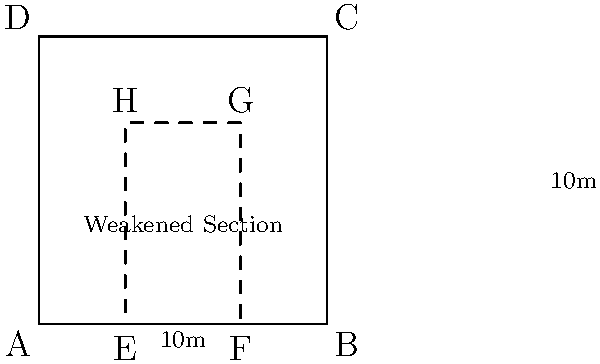In an abandoned building, you notice a weakened section in the wall as shown in the cross-section diagram. If the building is 10m x 10m and the weakened section covers 40% of the wall's width and 70% of its height, what is the area of the structurally compromised section in square meters? Let's break this down step-by-step:

1. First, we need to calculate the dimensions of the weakened section:
   - Width of the weakened section: 40% of 10m = $0.4 \times 10\text{m} = 4\text{m}$
   - Height of the weakened section: 70% of 10m = $0.7 \times 10\text{m} = 7\text{m}$

2. Now that we have the dimensions, we can calculate the area of the weakened section:
   Area = Width $\times$ Height
   $A = 4\text{m} \times 7\text{m} = 28\text{m}^2$

Therefore, the area of the structurally compromised section is 28 square meters.
Answer: $28\text{m}^2$ 